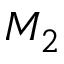Convert formula to latex. <formula><loc_0><loc_0><loc_500><loc_500>M _ { 2 }</formula> 